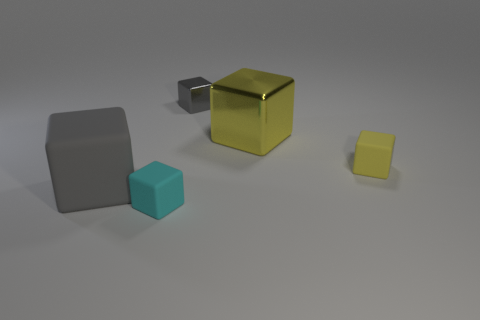Subtract all cyan cubes. How many cubes are left? 4 Subtract all gray blocks. How many blocks are left? 3 Subtract 1 blocks. How many blocks are left? 4 Add 1 large shiny things. How many objects exist? 6 Subtract all tiny yellow matte blocks. Subtract all big gray cubes. How many objects are left? 3 Add 4 gray cubes. How many gray cubes are left? 6 Add 1 red spheres. How many red spheres exist? 1 Subtract 0 yellow cylinders. How many objects are left? 5 Subtract all green blocks. Subtract all brown cylinders. How many blocks are left? 5 Subtract all blue cylinders. How many yellow cubes are left? 2 